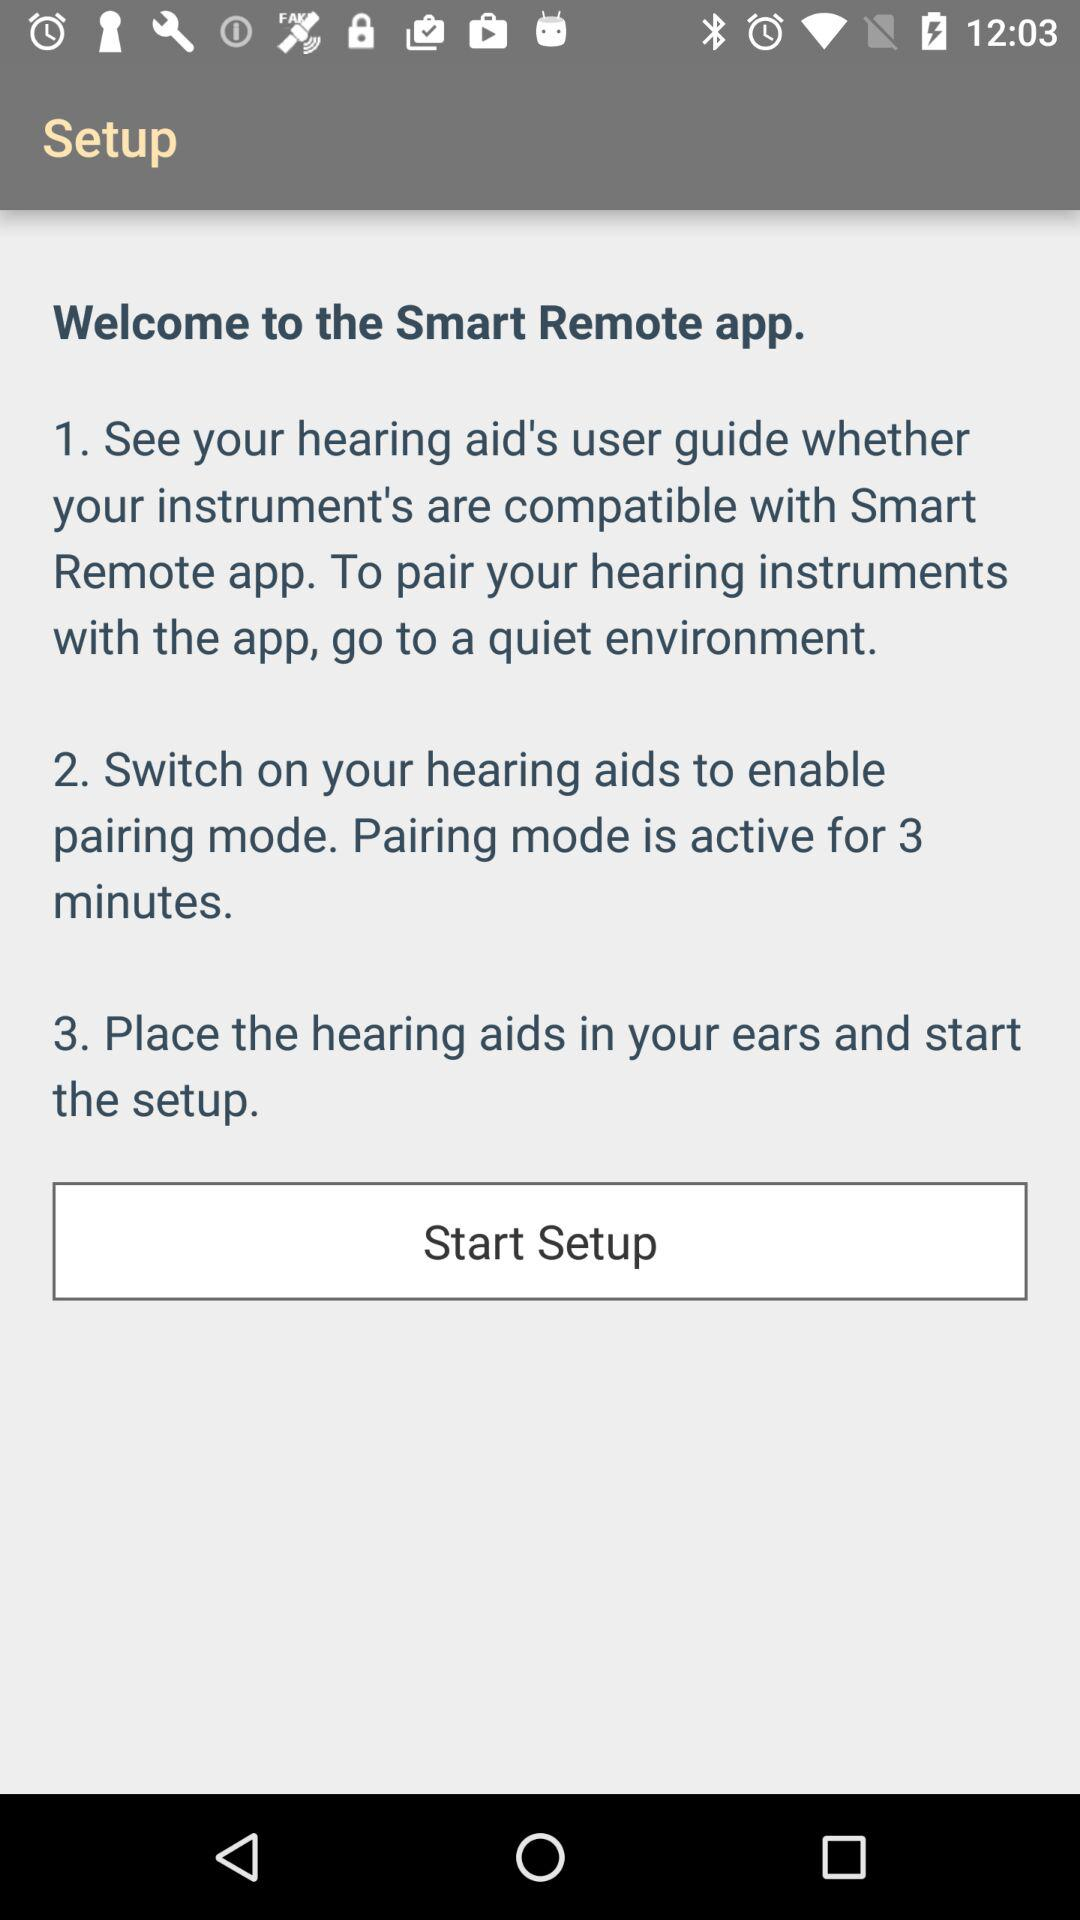How long is the pairing mode active for?
Answer the question using a single word or phrase. 3 minutes 